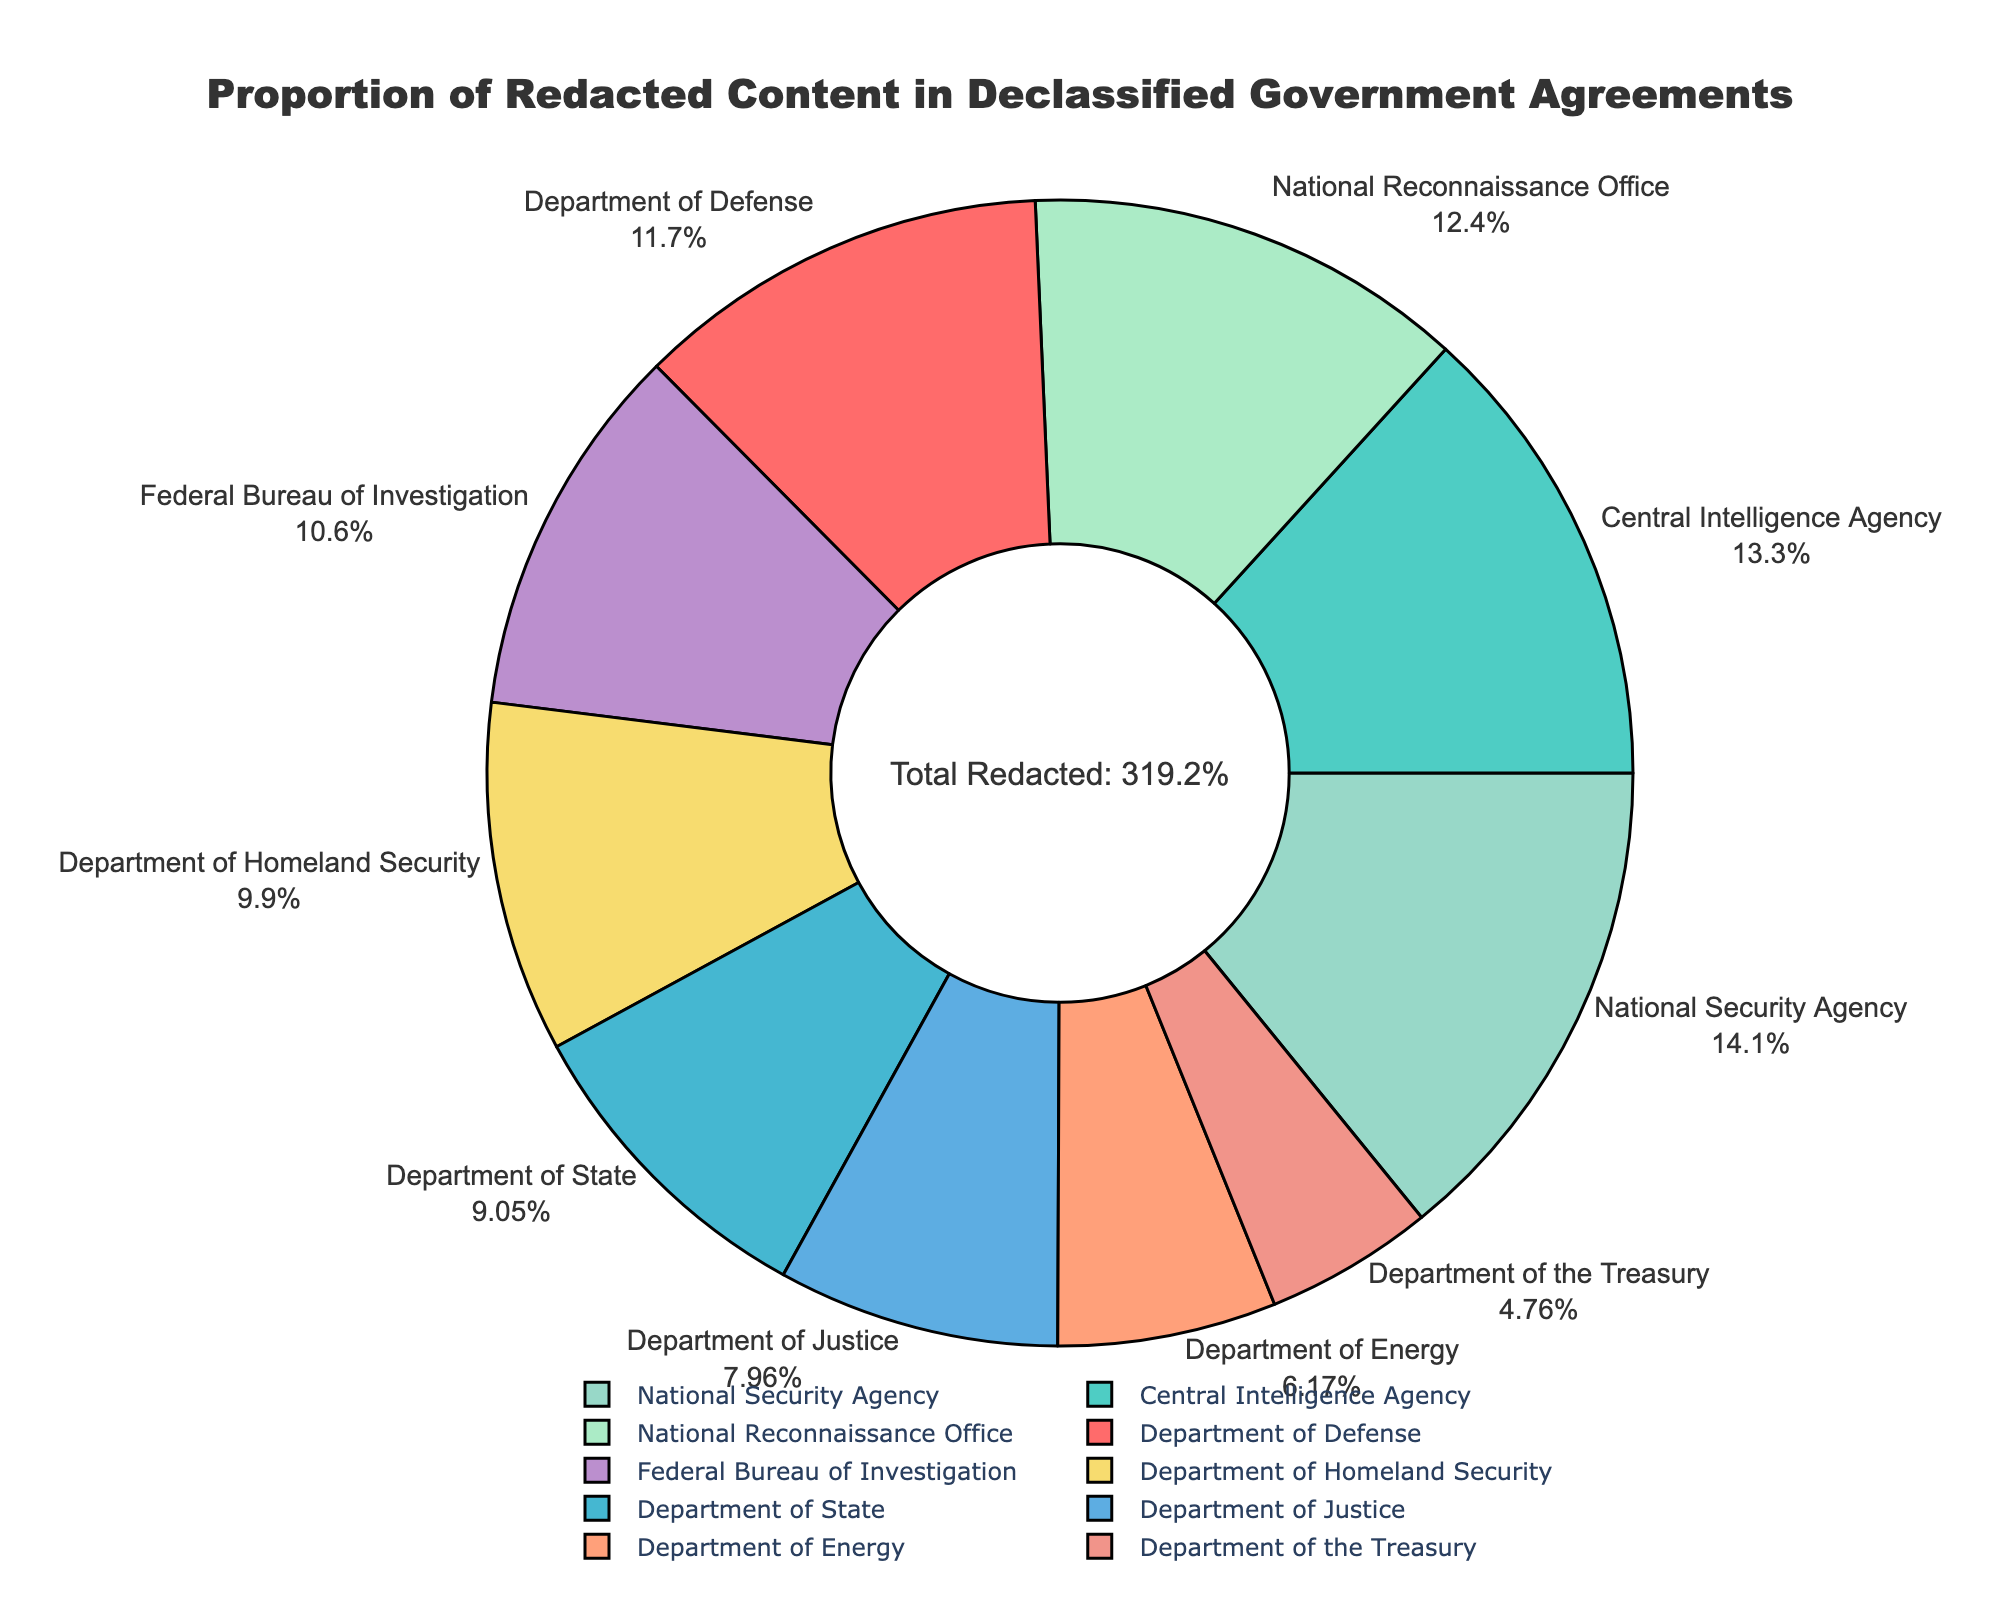Which department has the highest proportion of redacted content? The National Security Agency (NSA) has the highest proportion of redacted content with 45.1% as shown on the pie chart, where it's the largest slice with NSA label and percentage outside it.
Answer: National Security Agency Which department has the lowest proportion of redacted content? The Department of the Treasury has the lowest proportion of redacted content with 15.2%, noted on the smallest slice with the corresponding label and percentage outside it.
Answer: Department of the Treasury How does the redacted percentage of the Department of Defense compare to the Department of Energy? The Department of Defense has a 37.5% redacted content, which is more than the Department of Energy's 19.7% redacted content as seen from comparing the slices corresponding to these departments.
Answer: Department of Defense What is the total redacted percentage of the Department of State and the Federal Bureau of Investigation combined? Add the redacted percentage of the Department of State (28.9%) and the Federal Bureau of Investigation (33.8%) to get 62.7%.
Answer: 62.7% Which department's redacted percentage is closest to the average redacted percentage across all departments? Calculate the average redacted percentage by summing all percentages and dividing by the number of departments, which is 31.92%. The Department of Homeland Security with 31.6% is closest to this average.
Answer: Department of Homeland Security How does the redacted percentage of the Central Intelligence Agency compare to the National Reconnaissance Office? The Central Intelligence Agency has 42.3% redacted content, which is slightly less than the National Reconnaissance Office's 39.7% redacted content, comparing the sizes of their respective slices.
Answer: Central Intelligence Agency What is the difference in redacted percentages between the Department of Justice and the National Security Agency? Subtract the redacted percentage of the Department of Justice (25.4%) from the National Security Agency (45.1%) to get 19.7%.
Answer: 19.7% What proportion of the redacted content does the Department of Homeland Security represent out of the total redacted content? The Department of Homeland Security consists of 31.6% of the total redacted content summing to 319.2%, so it represents approximately 9.9% of the total redacted content.
Answer: 9.9% What is the median redacted percentage among the departments? First, arrange the redacted percentages in ascending order: 15.2, 19.7, 25.4, 28.9, 31.6, 33.8, 37.5, 39.7, 42.3, 45.1. As there are 10 values, the median is the average of the 5th and 6th values (31.6 and 33.8), which is 32.7%.
Answer: 32.7% 